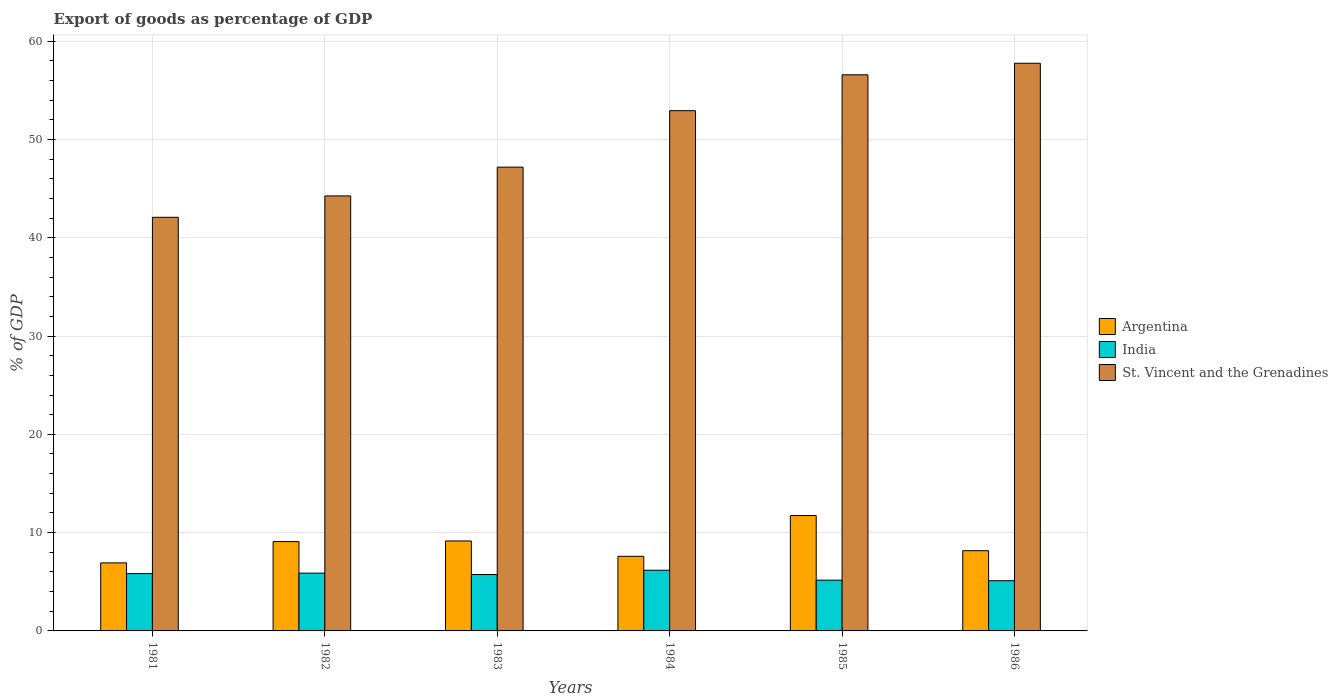Are the number of bars on each tick of the X-axis equal?
Your answer should be very brief. Yes. How many bars are there on the 6th tick from the right?
Offer a very short reply. 3. In how many cases, is the number of bars for a given year not equal to the number of legend labels?
Make the answer very short. 0. What is the export of goods as percentage of GDP in India in 1986?
Provide a succinct answer. 5.11. Across all years, what is the maximum export of goods as percentage of GDP in St. Vincent and the Grenadines?
Offer a terse response. 57.75. Across all years, what is the minimum export of goods as percentage of GDP in Argentina?
Your response must be concise. 6.92. In which year was the export of goods as percentage of GDP in St. Vincent and the Grenadines maximum?
Offer a terse response. 1986. What is the total export of goods as percentage of GDP in India in the graph?
Offer a very short reply. 33.9. What is the difference between the export of goods as percentage of GDP in St. Vincent and the Grenadines in 1984 and that in 1985?
Make the answer very short. -3.65. What is the difference between the export of goods as percentage of GDP in St. Vincent and the Grenadines in 1983 and the export of goods as percentage of GDP in Argentina in 1985?
Ensure brevity in your answer.  35.45. What is the average export of goods as percentage of GDP in St. Vincent and the Grenadines per year?
Offer a terse response. 50.13. In the year 1985, what is the difference between the export of goods as percentage of GDP in St. Vincent and the Grenadines and export of goods as percentage of GDP in India?
Ensure brevity in your answer.  51.41. In how many years, is the export of goods as percentage of GDP in St. Vincent and the Grenadines greater than 46 %?
Give a very brief answer. 4. What is the ratio of the export of goods as percentage of GDP in St. Vincent and the Grenadines in 1983 to that in 1986?
Provide a short and direct response. 0.82. Is the export of goods as percentage of GDP in India in 1983 less than that in 1985?
Make the answer very short. No. Is the difference between the export of goods as percentage of GDP in St. Vincent and the Grenadines in 1982 and 1986 greater than the difference between the export of goods as percentage of GDP in India in 1982 and 1986?
Your response must be concise. No. What is the difference between the highest and the second highest export of goods as percentage of GDP in St. Vincent and the Grenadines?
Offer a very short reply. 1.17. What is the difference between the highest and the lowest export of goods as percentage of GDP in India?
Provide a short and direct response. 1.07. In how many years, is the export of goods as percentage of GDP in India greater than the average export of goods as percentage of GDP in India taken over all years?
Keep it short and to the point. 4. What does the 1st bar from the left in 1985 represents?
Make the answer very short. Argentina. Is it the case that in every year, the sum of the export of goods as percentage of GDP in St. Vincent and the Grenadines and export of goods as percentage of GDP in India is greater than the export of goods as percentage of GDP in Argentina?
Your answer should be very brief. Yes. Are all the bars in the graph horizontal?
Your answer should be compact. No. What is the difference between two consecutive major ticks on the Y-axis?
Make the answer very short. 10. Does the graph contain any zero values?
Keep it short and to the point. No. Where does the legend appear in the graph?
Offer a terse response. Center right. What is the title of the graph?
Your response must be concise. Export of goods as percentage of GDP. Does "St. Vincent and the Grenadines" appear as one of the legend labels in the graph?
Offer a terse response. Yes. What is the label or title of the X-axis?
Offer a terse response. Years. What is the label or title of the Y-axis?
Make the answer very short. % of GDP. What is the % of GDP of Argentina in 1981?
Ensure brevity in your answer.  6.92. What is the % of GDP of India in 1981?
Your response must be concise. 5.83. What is the % of GDP of St. Vincent and the Grenadines in 1981?
Your response must be concise. 42.08. What is the % of GDP of Argentina in 1982?
Make the answer very short. 9.09. What is the % of GDP of India in 1982?
Offer a terse response. 5.88. What is the % of GDP of St. Vincent and the Grenadines in 1982?
Keep it short and to the point. 44.26. What is the % of GDP of Argentina in 1983?
Keep it short and to the point. 9.15. What is the % of GDP of India in 1983?
Make the answer very short. 5.74. What is the % of GDP in St. Vincent and the Grenadines in 1983?
Make the answer very short. 47.18. What is the % of GDP in Argentina in 1984?
Provide a short and direct response. 7.59. What is the % of GDP in India in 1984?
Your answer should be very brief. 6.18. What is the % of GDP in St. Vincent and the Grenadines in 1984?
Ensure brevity in your answer.  52.93. What is the % of GDP in Argentina in 1985?
Offer a terse response. 11.74. What is the % of GDP in India in 1985?
Keep it short and to the point. 5.16. What is the % of GDP of St. Vincent and the Grenadines in 1985?
Offer a terse response. 56.58. What is the % of GDP of Argentina in 1986?
Offer a terse response. 8.16. What is the % of GDP of India in 1986?
Give a very brief answer. 5.11. What is the % of GDP of St. Vincent and the Grenadines in 1986?
Give a very brief answer. 57.75. Across all years, what is the maximum % of GDP of Argentina?
Provide a short and direct response. 11.74. Across all years, what is the maximum % of GDP in India?
Your answer should be very brief. 6.18. Across all years, what is the maximum % of GDP in St. Vincent and the Grenadines?
Your answer should be compact. 57.75. Across all years, what is the minimum % of GDP in Argentina?
Your response must be concise. 6.92. Across all years, what is the minimum % of GDP of India?
Your response must be concise. 5.11. Across all years, what is the minimum % of GDP of St. Vincent and the Grenadines?
Offer a very short reply. 42.08. What is the total % of GDP of Argentina in the graph?
Your answer should be compact. 52.65. What is the total % of GDP of India in the graph?
Your answer should be very brief. 33.9. What is the total % of GDP in St. Vincent and the Grenadines in the graph?
Your answer should be compact. 300.77. What is the difference between the % of GDP in Argentina in 1981 and that in 1982?
Offer a very short reply. -2.17. What is the difference between the % of GDP of India in 1981 and that in 1982?
Keep it short and to the point. -0.05. What is the difference between the % of GDP in St. Vincent and the Grenadines in 1981 and that in 1982?
Make the answer very short. -2.18. What is the difference between the % of GDP in Argentina in 1981 and that in 1983?
Offer a very short reply. -2.23. What is the difference between the % of GDP of India in 1981 and that in 1983?
Provide a succinct answer. 0.1. What is the difference between the % of GDP of St. Vincent and the Grenadines in 1981 and that in 1983?
Your response must be concise. -5.1. What is the difference between the % of GDP of Argentina in 1981 and that in 1984?
Provide a succinct answer. -0.67. What is the difference between the % of GDP of India in 1981 and that in 1984?
Your answer should be very brief. -0.34. What is the difference between the % of GDP of St. Vincent and the Grenadines in 1981 and that in 1984?
Offer a terse response. -10.85. What is the difference between the % of GDP in Argentina in 1981 and that in 1985?
Offer a very short reply. -4.82. What is the difference between the % of GDP of India in 1981 and that in 1985?
Provide a succinct answer. 0.67. What is the difference between the % of GDP in St. Vincent and the Grenadines in 1981 and that in 1985?
Provide a short and direct response. -14.5. What is the difference between the % of GDP of Argentina in 1981 and that in 1986?
Give a very brief answer. -1.24. What is the difference between the % of GDP in India in 1981 and that in 1986?
Your answer should be very brief. 0.73. What is the difference between the % of GDP of St. Vincent and the Grenadines in 1981 and that in 1986?
Offer a terse response. -15.67. What is the difference between the % of GDP in Argentina in 1982 and that in 1983?
Your answer should be compact. -0.06. What is the difference between the % of GDP of India in 1982 and that in 1983?
Keep it short and to the point. 0.14. What is the difference between the % of GDP in St. Vincent and the Grenadines in 1982 and that in 1983?
Your answer should be very brief. -2.93. What is the difference between the % of GDP in Argentina in 1982 and that in 1984?
Keep it short and to the point. 1.5. What is the difference between the % of GDP of India in 1982 and that in 1984?
Make the answer very short. -0.29. What is the difference between the % of GDP of St. Vincent and the Grenadines in 1982 and that in 1984?
Offer a terse response. -8.67. What is the difference between the % of GDP in Argentina in 1982 and that in 1985?
Provide a succinct answer. -2.65. What is the difference between the % of GDP in India in 1982 and that in 1985?
Make the answer very short. 0.72. What is the difference between the % of GDP of St. Vincent and the Grenadines in 1982 and that in 1985?
Ensure brevity in your answer.  -12.32. What is the difference between the % of GDP in Argentina in 1982 and that in 1986?
Provide a succinct answer. 0.93. What is the difference between the % of GDP in India in 1982 and that in 1986?
Offer a very short reply. 0.77. What is the difference between the % of GDP of St. Vincent and the Grenadines in 1982 and that in 1986?
Your answer should be compact. -13.49. What is the difference between the % of GDP of Argentina in 1983 and that in 1984?
Your answer should be very brief. 1.56. What is the difference between the % of GDP in India in 1983 and that in 1984?
Keep it short and to the point. -0.44. What is the difference between the % of GDP of St. Vincent and the Grenadines in 1983 and that in 1984?
Offer a terse response. -5.74. What is the difference between the % of GDP in Argentina in 1983 and that in 1985?
Provide a short and direct response. -2.58. What is the difference between the % of GDP of India in 1983 and that in 1985?
Your answer should be very brief. 0.57. What is the difference between the % of GDP of St. Vincent and the Grenadines in 1983 and that in 1985?
Offer a very short reply. -9.4. What is the difference between the % of GDP in Argentina in 1983 and that in 1986?
Your response must be concise. 0.99. What is the difference between the % of GDP in India in 1983 and that in 1986?
Your answer should be compact. 0.63. What is the difference between the % of GDP of St. Vincent and the Grenadines in 1983 and that in 1986?
Your answer should be compact. -10.57. What is the difference between the % of GDP of Argentina in 1984 and that in 1985?
Offer a very short reply. -4.15. What is the difference between the % of GDP of India in 1984 and that in 1985?
Give a very brief answer. 1.01. What is the difference between the % of GDP of St. Vincent and the Grenadines in 1984 and that in 1985?
Offer a very short reply. -3.65. What is the difference between the % of GDP of Argentina in 1984 and that in 1986?
Keep it short and to the point. -0.57. What is the difference between the % of GDP of India in 1984 and that in 1986?
Your response must be concise. 1.07. What is the difference between the % of GDP in St. Vincent and the Grenadines in 1984 and that in 1986?
Give a very brief answer. -4.82. What is the difference between the % of GDP in Argentina in 1985 and that in 1986?
Provide a short and direct response. 3.57. What is the difference between the % of GDP of India in 1985 and that in 1986?
Your response must be concise. 0.06. What is the difference between the % of GDP of St. Vincent and the Grenadines in 1985 and that in 1986?
Provide a short and direct response. -1.17. What is the difference between the % of GDP of Argentina in 1981 and the % of GDP of India in 1982?
Provide a short and direct response. 1.04. What is the difference between the % of GDP in Argentina in 1981 and the % of GDP in St. Vincent and the Grenadines in 1982?
Offer a terse response. -37.33. What is the difference between the % of GDP of India in 1981 and the % of GDP of St. Vincent and the Grenadines in 1982?
Offer a very short reply. -38.42. What is the difference between the % of GDP in Argentina in 1981 and the % of GDP in India in 1983?
Keep it short and to the point. 1.18. What is the difference between the % of GDP of Argentina in 1981 and the % of GDP of St. Vincent and the Grenadines in 1983?
Keep it short and to the point. -40.26. What is the difference between the % of GDP of India in 1981 and the % of GDP of St. Vincent and the Grenadines in 1983?
Ensure brevity in your answer.  -41.35. What is the difference between the % of GDP of Argentina in 1981 and the % of GDP of India in 1984?
Your answer should be very brief. 0.75. What is the difference between the % of GDP of Argentina in 1981 and the % of GDP of St. Vincent and the Grenadines in 1984?
Provide a short and direct response. -46. What is the difference between the % of GDP in India in 1981 and the % of GDP in St. Vincent and the Grenadines in 1984?
Ensure brevity in your answer.  -47.09. What is the difference between the % of GDP of Argentina in 1981 and the % of GDP of India in 1985?
Your response must be concise. 1.76. What is the difference between the % of GDP in Argentina in 1981 and the % of GDP in St. Vincent and the Grenadines in 1985?
Your answer should be compact. -49.66. What is the difference between the % of GDP of India in 1981 and the % of GDP of St. Vincent and the Grenadines in 1985?
Provide a succinct answer. -50.74. What is the difference between the % of GDP of Argentina in 1981 and the % of GDP of India in 1986?
Ensure brevity in your answer.  1.81. What is the difference between the % of GDP of Argentina in 1981 and the % of GDP of St. Vincent and the Grenadines in 1986?
Your answer should be compact. -50.83. What is the difference between the % of GDP in India in 1981 and the % of GDP in St. Vincent and the Grenadines in 1986?
Provide a succinct answer. -51.92. What is the difference between the % of GDP in Argentina in 1982 and the % of GDP in India in 1983?
Your answer should be compact. 3.35. What is the difference between the % of GDP of Argentina in 1982 and the % of GDP of St. Vincent and the Grenadines in 1983?
Make the answer very short. -38.09. What is the difference between the % of GDP of India in 1982 and the % of GDP of St. Vincent and the Grenadines in 1983?
Give a very brief answer. -41.3. What is the difference between the % of GDP of Argentina in 1982 and the % of GDP of India in 1984?
Your response must be concise. 2.92. What is the difference between the % of GDP in Argentina in 1982 and the % of GDP in St. Vincent and the Grenadines in 1984?
Offer a terse response. -43.84. What is the difference between the % of GDP in India in 1982 and the % of GDP in St. Vincent and the Grenadines in 1984?
Your response must be concise. -47.05. What is the difference between the % of GDP of Argentina in 1982 and the % of GDP of India in 1985?
Ensure brevity in your answer.  3.93. What is the difference between the % of GDP of Argentina in 1982 and the % of GDP of St. Vincent and the Grenadines in 1985?
Make the answer very short. -47.49. What is the difference between the % of GDP in India in 1982 and the % of GDP in St. Vincent and the Grenadines in 1985?
Provide a short and direct response. -50.7. What is the difference between the % of GDP in Argentina in 1982 and the % of GDP in India in 1986?
Offer a very short reply. 3.98. What is the difference between the % of GDP of Argentina in 1982 and the % of GDP of St. Vincent and the Grenadines in 1986?
Keep it short and to the point. -48.66. What is the difference between the % of GDP in India in 1982 and the % of GDP in St. Vincent and the Grenadines in 1986?
Ensure brevity in your answer.  -51.87. What is the difference between the % of GDP in Argentina in 1983 and the % of GDP in India in 1984?
Give a very brief answer. 2.98. What is the difference between the % of GDP in Argentina in 1983 and the % of GDP in St. Vincent and the Grenadines in 1984?
Provide a succinct answer. -43.77. What is the difference between the % of GDP of India in 1983 and the % of GDP of St. Vincent and the Grenadines in 1984?
Offer a very short reply. -47.19. What is the difference between the % of GDP in Argentina in 1983 and the % of GDP in India in 1985?
Offer a terse response. 3.99. What is the difference between the % of GDP of Argentina in 1983 and the % of GDP of St. Vincent and the Grenadines in 1985?
Your answer should be compact. -47.43. What is the difference between the % of GDP in India in 1983 and the % of GDP in St. Vincent and the Grenadines in 1985?
Offer a terse response. -50.84. What is the difference between the % of GDP in Argentina in 1983 and the % of GDP in India in 1986?
Keep it short and to the point. 4.04. What is the difference between the % of GDP in Argentina in 1983 and the % of GDP in St. Vincent and the Grenadines in 1986?
Your answer should be compact. -48.6. What is the difference between the % of GDP of India in 1983 and the % of GDP of St. Vincent and the Grenadines in 1986?
Your answer should be very brief. -52.01. What is the difference between the % of GDP of Argentina in 1984 and the % of GDP of India in 1985?
Provide a succinct answer. 2.43. What is the difference between the % of GDP in Argentina in 1984 and the % of GDP in St. Vincent and the Grenadines in 1985?
Your answer should be compact. -48.99. What is the difference between the % of GDP in India in 1984 and the % of GDP in St. Vincent and the Grenadines in 1985?
Your response must be concise. -50.4. What is the difference between the % of GDP of Argentina in 1984 and the % of GDP of India in 1986?
Keep it short and to the point. 2.48. What is the difference between the % of GDP of Argentina in 1984 and the % of GDP of St. Vincent and the Grenadines in 1986?
Keep it short and to the point. -50.16. What is the difference between the % of GDP of India in 1984 and the % of GDP of St. Vincent and the Grenadines in 1986?
Offer a terse response. -51.57. What is the difference between the % of GDP in Argentina in 1985 and the % of GDP in India in 1986?
Your answer should be very brief. 6.63. What is the difference between the % of GDP in Argentina in 1985 and the % of GDP in St. Vincent and the Grenadines in 1986?
Offer a terse response. -46.01. What is the difference between the % of GDP of India in 1985 and the % of GDP of St. Vincent and the Grenadines in 1986?
Make the answer very short. -52.59. What is the average % of GDP in Argentina per year?
Your response must be concise. 8.78. What is the average % of GDP in India per year?
Offer a very short reply. 5.65. What is the average % of GDP in St. Vincent and the Grenadines per year?
Make the answer very short. 50.13. In the year 1981, what is the difference between the % of GDP in Argentina and % of GDP in India?
Ensure brevity in your answer.  1.09. In the year 1981, what is the difference between the % of GDP of Argentina and % of GDP of St. Vincent and the Grenadines?
Provide a short and direct response. -35.16. In the year 1981, what is the difference between the % of GDP in India and % of GDP in St. Vincent and the Grenadines?
Give a very brief answer. -36.24. In the year 1982, what is the difference between the % of GDP in Argentina and % of GDP in India?
Provide a short and direct response. 3.21. In the year 1982, what is the difference between the % of GDP of Argentina and % of GDP of St. Vincent and the Grenadines?
Your answer should be compact. -35.16. In the year 1982, what is the difference between the % of GDP in India and % of GDP in St. Vincent and the Grenadines?
Offer a terse response. -38.38. In the year 1983, what is the difference between the % of GDP in Argentina and % of GDP in India?
Ensure brevity in your answer.  3.41. In the year 1983, what is the difference between the % of GDP of Argentina and % of GDP of St. Vincent and the Grenadines?
Make the answer very short. -38.03. In the year 1983, what is the difference between the % of GDP of India and % of GDP of St. Vincent and the Grenadines?
Offer a terse response. -41.44. In the year 1984, what is the difference between the % of GDP of Argentina and % of GDP of India?
Give a very brief answer. 1.41. In the year 1984, what is the difference between the % of GDP in Argentina and % of GDP in St. Vincent and the Grenadines?
Make the answer very short. -45.34. In the year 1984, what is the difference between the % of GDP in India and % of GDP in St. Vincent and the Grenadines?
Your answer should be very brief. -46.75. In the year 1985, what is the difference between the % of GDP of Argentina and % of GDP of India?
Offer a terse response. 6.57. In the year 1985, what is the difference between the % of GDP of Argentina and % of GDP of St. Vincent and the Grenadines?
Give a very brief answer. -44.84. In the year 1985, what is the difference between the % of GDP in India and % of GDP in St. Vincent and the Grenadines?
Keep it short and to the point. -51.41. In the year 1986, what is the difference between the % of GDP in Argentina and % of GDP in India?
Offer a very short reply. 3.06. In the year 1986, what is the difference between the % of GDP in Argentina and % of GDP in St. Vincent and the Grenadines?
Provide a succinct answer. -49.59. In the year 1986, what is the difference between the % of GDP in India and % of GDP in St. Vincent and the Grenadines?
Give a very brief answer. -52.64. What is the ratio of the % of GDP in Argentina in 1981 to that in 1982?
Keep it short and to the point. 0.76. What is the ratio of the % of GDP of India in 1981 to that in 1982?
Your answer should be very brief. 0.99. What is the ratio of the % of GDP of St. Vincent and the Grenadines in 1981 to that in 1982?
Provide a short and direct response. 0.95. What is the ratio of the % of GDP in Argentina in 1981 to that in 1983?
Offer a terse response. 0.76. What is the ratio of the % of GDP in India in 1981 to that in 1983?
Provide a succinct answer. 1.02. What is the ratio of the % of GDP of St. Vincent and the Grenadines in 1981 to that in 1983?
Provide a short and direct response. 0.89. What is the ratio of the % of GDP in Argentina in 1981 to that in 1984?
Ensure brevity in your answer.  0.91. What is the ratio of the % of GDP in India in 1981 to that in 1984?
Ensure brevity in your answer.  0.94. What is the ratio of the % of GDP of St. Vincent and the Grenadines in 1981 to that in 1984?
Your answer should be very brief. 0.8. What is the ratio of the % of GDP in Argentina in 1981 to that in 1985?
Make the answer very short. 0.59. What is the ratio of the % of GDP of India in 1981 to that in 1985?
Offer a very short reply. 1.13. What is the ratio of the % of GDP of St. Vincent and the Grenadines in 1981 to that in 1985?
Offer a very short reply. 0.74. What is the ratio of the % of GDP of Argentina in 1981 to that in 1986?
Your answer should be very brief. 0.85. What is the ratio of the % of GDP of India in 1981 to that in 1986?
Offer a very short reply. 1.14. What is the ratio of the % of GDP in St. Vincent and the Grenadines in 1981 to that in 1986?
Ensure brevity in your answer.  0.73. What is the ratio of the % of GDP of Argentina in 1982 to that in 1983?
Your answer should be very brief. 0.99. What is the ratio of the % of GDP in St. Vincent and the Grenadines in 1982 to that in 1983?
Keep it short and to the point. 0.94. What is the ratio of the % of GDP of Argentina in 1982 to that in 1984?
Your response must be concise. 1.2. What is the ratio of the % of GDP of India in 1982 to that in 1984?
Keep it short and to the point. 0.95. What is the ratio of the % of GDP in St. Vincent and the Grenadines in 1982 to that in 1984?
Provide a short and direct response. 0.84. What is the ratio of the % of GDP of Argentina in 1982 to that in 1985?
Make the answer very short. 0.77. What is the ratio of the % of GDP of India in 1982 to that in 1985?
Ensure brevity in your answer.  1.14. What is the ratio of the % of GDP in St. Vincent and the Grenadines in 1982 to that in 1985?
Your response must be concise. 0.78. What is the ratio of the % of GDP in Argentina in 1982 to that in 1986?
Keep it short and to the point. 1.11. What is the ratio of the % of GDP of India in 1982 to that in 1986?
Keep it short and to the point. 1.15. What is the ratio of the % of GDP of St. Vincent and the Grenadines in 1982 to that in 1986?
Your response must be concise. 0.77. What is the ratio of the % of GDP of Argentina in 1983 to that in 1984?
Make the answer very short. 1.21. What is the ratio of the % of GDP of India in 1983 to that in 1984?
Make the answer very short. 0.93. What is the ratio of the % of GDP in St. Vincent and the Grenadines in 1983 to that in 1984?
Give a very brief answer. 0.89. What is the ratio of the % of GDP in Argentina in 1983 to that in 1985?
Provide a short and direct response. 0.78. What is the ratio of the % of GDP in India in 1983 to that in 1985?
Your answer should be very brief. 1.11. What is the ratio of the % of GDP in St. Vincent and the Grenadines in 1983 to that in 1985?
Provide a short and direct response. 0.83. What is the ratio of the % of GDP in Argentina in 1983 to that in 1986?
Make the answer very short. 1.12. What is the ratio of the % of GDP in India in 1983 to that in 1986?
Ensure brevity in your answer.  1.12. What is the ratio of the % of GDP of St. Vincent and the Grenadines in 1983 to that in 1986?
Your response must be concise. 0.82. What is the ratio of the % of GDP in Argentina in 1984 to that in 1985?
Offer a very short reply. 0.65. What is the ratio of the % of GDP in India in 1984 to that in 1985?
Offer a terse response. 1.2. What is the ratio of the % of GDP in St. Vincent and the Grenadines in 1984 to that in 1985?
Offer a very short reply. 0.94. What is the ratio of the % of GDP of Argentina in 1984 to that in 1986?
Provide a succinct answer. 0.93. What is the ratio of the % of GDP in India in 1984 to that in 1986?
Your answer should be compact. 1.21. What is the ratio of the % of GDP of St. Vincent and the Grenadines in 1984 to that in 1986?
Provide a short and direct response. 0.92. What is the ratio of the % of GDP in Argentina in 1985 to that in 1986?
Give a very brief answer. 1.44. What is the ratio of the % of GDP in India in 1985 to that in 1986?
Give a very brief answer. 1.01. What is the ratio of the % of GDP in St. Vincent and the Grenadines in 1985 to that in 1986?
Provide a short and direct response. 0.98. What is the difference between the highest and the second highest % of GDP of Argentina?
Your response must be concise. 2.58. What is the difference between the highest and the second highest % of GDP in India?
Keep it short and to the point. 0.29. What is the difference between the highest and the second highest % of GDP of St. Vincent and the Grenadines?
Make the answer very short. 1.17. What is the difference between the highest and the lowest % of GDP in Argentina?
Ensure brevity in your answer.  4.82. What is the difference between the highest and the lowest % of GDP in India?
Give a very brief answer. 1.07. What is the difference between the highest and the lowest % of GDP in St. Vincent and the Grenadines?
Your answer should be very brief. 15.67. 